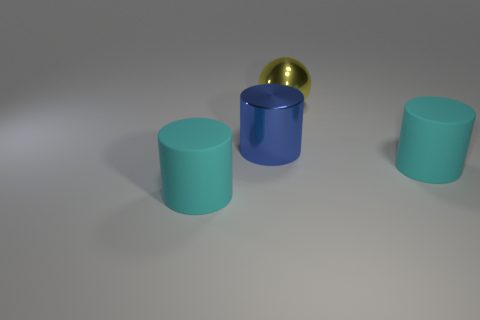What material is the blue cylinder that is the same size as the sphere?
Your answer should be compact. Metal. There is a big metallic cylinder; is it the same color as the big object that is on the left side of the blue object?
Provide a succinct answer. No. Are there fewer large blue cylinders that are behind the big blue metal object than small cyan rubber blocks?
Provide a succinct answer. No. What number of big cyan matte cylinders are there?
Provide a succinct answer. 2. The rubber thing that is in front of the cylinder to the right of the big ball is what shape?
Give a very brief answer. Cylinder. What number of big yellow things are on the left side of the big blue shiny object?
Provide a succinct answer. 0. Are the yellow sphere and the big cyan cylinder that is right of the big blue cylinder made of the same material?
Keep it short and to the point. No. Are there any red matte balls of the same size as the shiny ball?
Ensure brevity in your answer.  No. Are there the same number of blue shiny cylinders that are in front of the big blue metallic object and metallic things?
Make the answer very short. No. What size is the metallic cylinder?
Give a very brief answer. Large. 